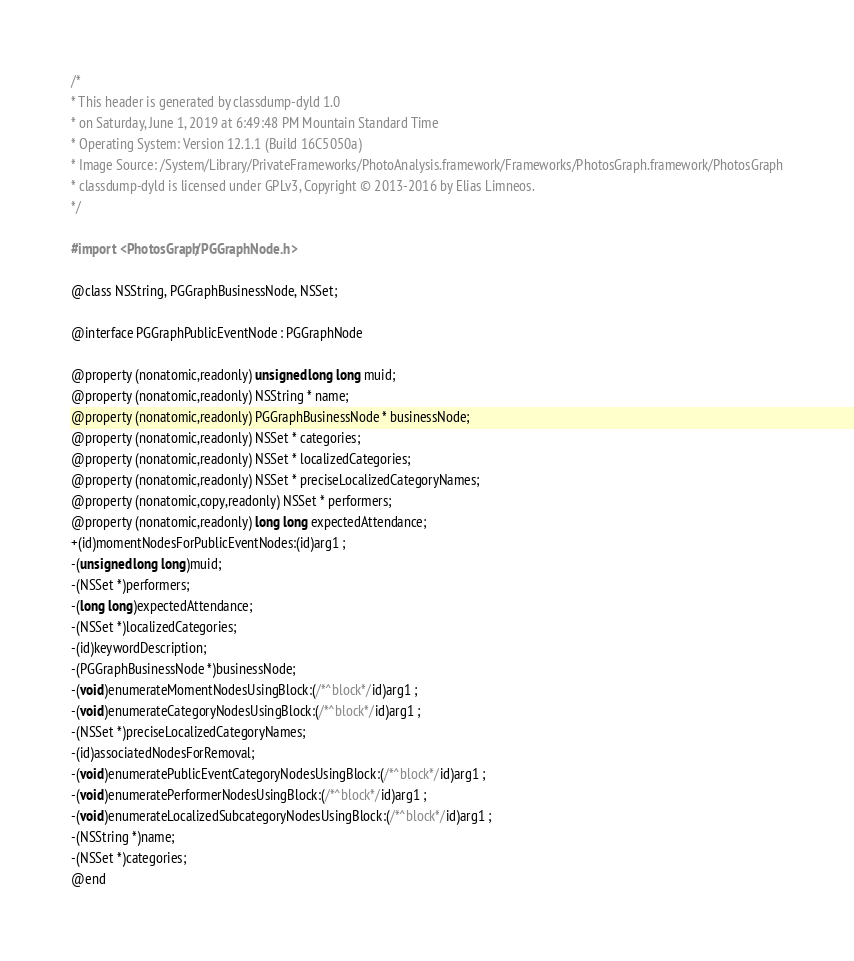Convert code to text. <code><loc_0><loc_0><loc_500><loc_500><_C_>/*
* This header is generated by classdump-dyld 1.0
* on Saturday, June 1, 2019 at 6:49:48 PM Mountain Standard Time
* Operating System: Version 12.1.1 (Build 16C5050a)
* Image Source: /System/Library/PrivateFrameworks/PhotoAnalysis.framework/Frameworks/PhotosGraph.framework/PhotosGraph
* classdump-dyld is licensed under GPLv3, Copyright © 2013-2016 by Elias Limneos.
*/

#import <PhotosGraph/PGGraphNode.h>

@class NSString, PGGraphBusinessNode, NSSet;

@interface PGGraphPublicEventNode : PGGraphNode

@property (nonatomic,readonly) unsigned long long muid; 
@property (nonatomic,readonly) NSString * name; 
@property (nonatomic,readonly) PGGraphBusinessNode * businessNode; 
@property (nonatomic,readonly) NSSet * categories; 
@property (nonatomic,readonly) NSSet * localizedCategories; 
@property (nonatomic,readonly) NSSet * preciseLocalizedCategoryNames; 
@property (nonatomic,copy,readonly) NSSet * performers; 
@property (nonatomic,readonly) long long expectedAttendance; 
+(id)momentNodesForPublicEventNodes:(id)arg1 ;
-(unsigned long long)muid;
-(NSSet *)performers;
-(long long)expectedAttendance;
-(NSSet *)localizedCategories;
-(id)keywordDescription;
-(PGGraphBusinessNode *)businessNode;
-(void)enumerateMomentNodesUsingBlock:(/*^block*/id)arg1 ;
-(void)enumerateCategoryNodesUsingBlock:(/*^block*/id)arg1 ;
-(NSSet *)preciseLocalizedCategoryNames;
-(id)associatedNodesForRemoval;
-(void)enumeratePublicEventCategoryNodesUsingBlock:(/*^block*/id)arg1 ;
-(void)enumeratePerformerNodesUsingBlock:(/*^block*/id)arg1 ;
-(void)enumerateLocalizedSubcategoryNodesUsingBlock:(/*^block*/id)arg1 ;
-(NSString *)name;
-(NSSet *)categories;
@end

</code> 